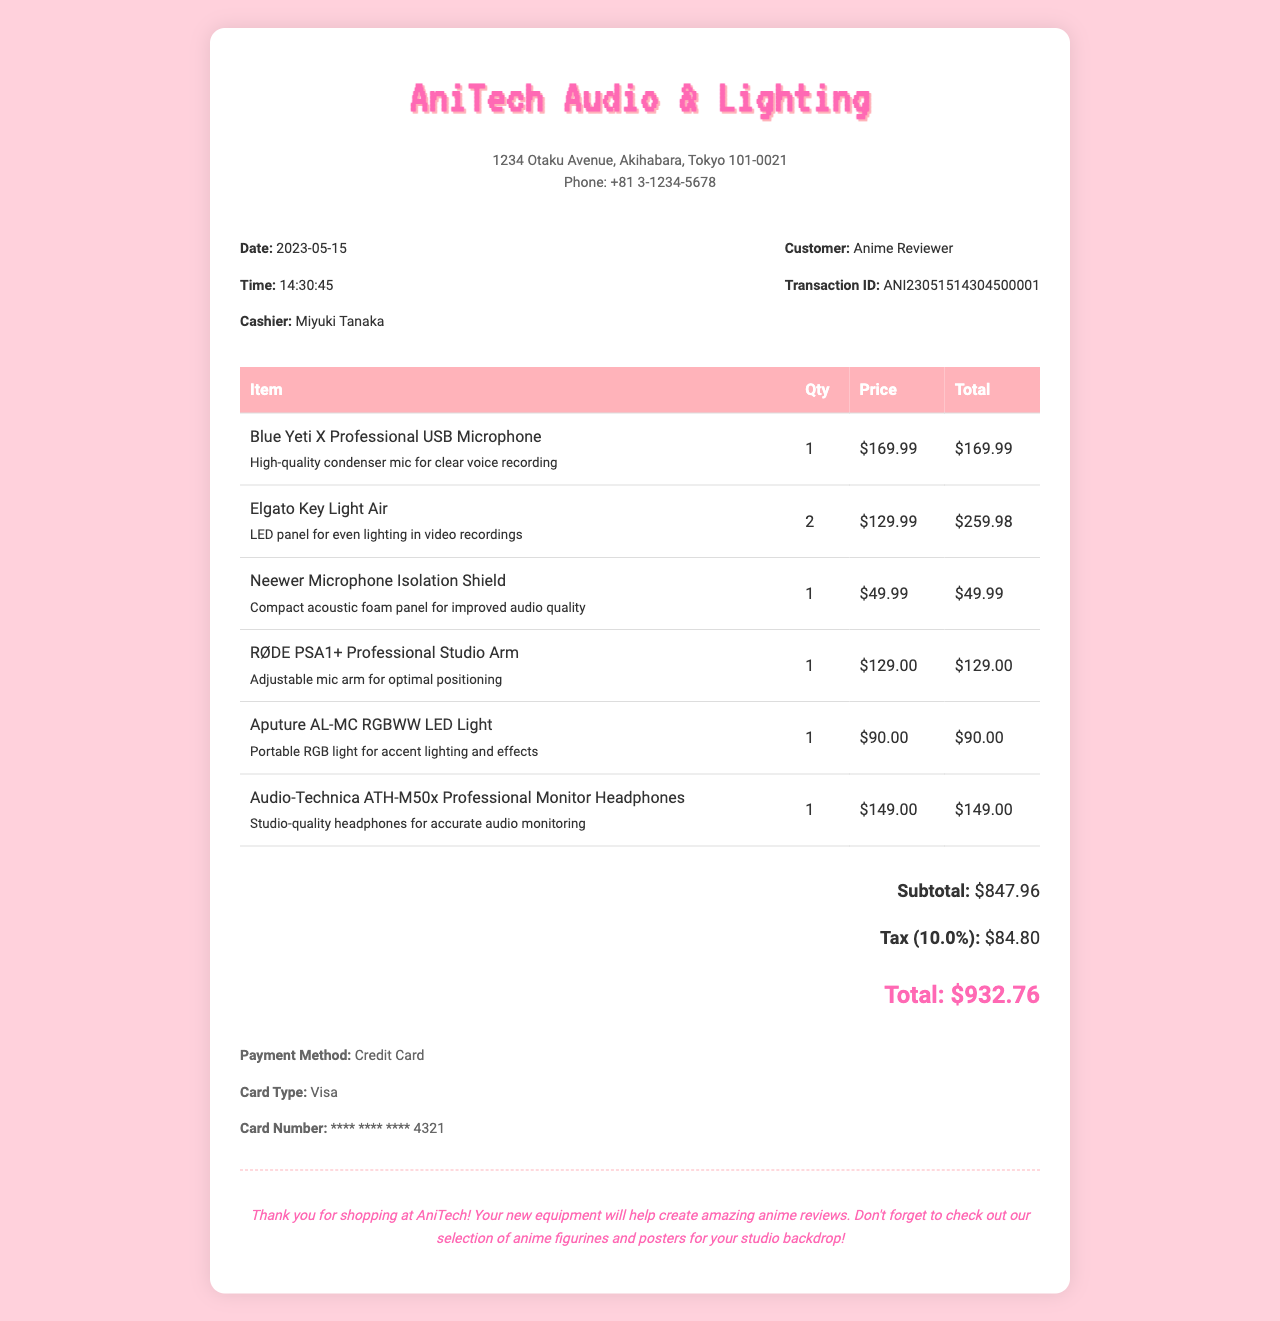What is the store name? The store name is prominently displayed at the top of the receipt.
Answer: AniTech Audio & Lighting What was purchased alongside the microphone? The receipt lists multiple items, one of which is a prominent piece of equipment.
Answer: Elgato Key Light Air What is the subtotal amount? The subtotal is the total cost of items before tax.
Answer: $847.96 Who was the cashier? The cashier's name appears under the transaction details of the receipt.
Answer: Miyuki Tanaka What is the total amount after tax? The total amount includes the subtotal and tax, stated clearly at the end of the receipt.
Answer: $932.76 How many Elgato Key Light Air were purchased? The number of items purchased is listed next to the item description on the receipt.
Answer: 2 What type of payment was used? The payment method is specified in the payment section of the receipt.
Answer: Credit Card What is the transaction ID? The unique transaction ID is provided to identify the purchase, appearing at the end of the transaction details.
Answer: ANI23051514304500001 What is one of the blessings stated in the notes? The notes section contains a positive message regarding the purchase experience.
Answer: Thank you for shopping at AniTech! 